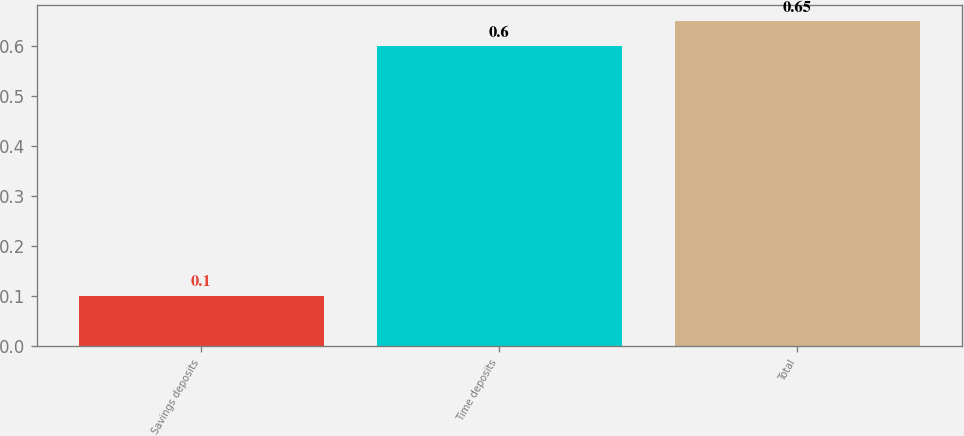<chart> <loc_0><loc_0><loc_500><loc_500><bar_chart><fcel>Savings deposits<fcel>Time deposits<fcel>Total<nl><fcel>0.1<fcel>0.6<fcel>0.65<nl></chart> 